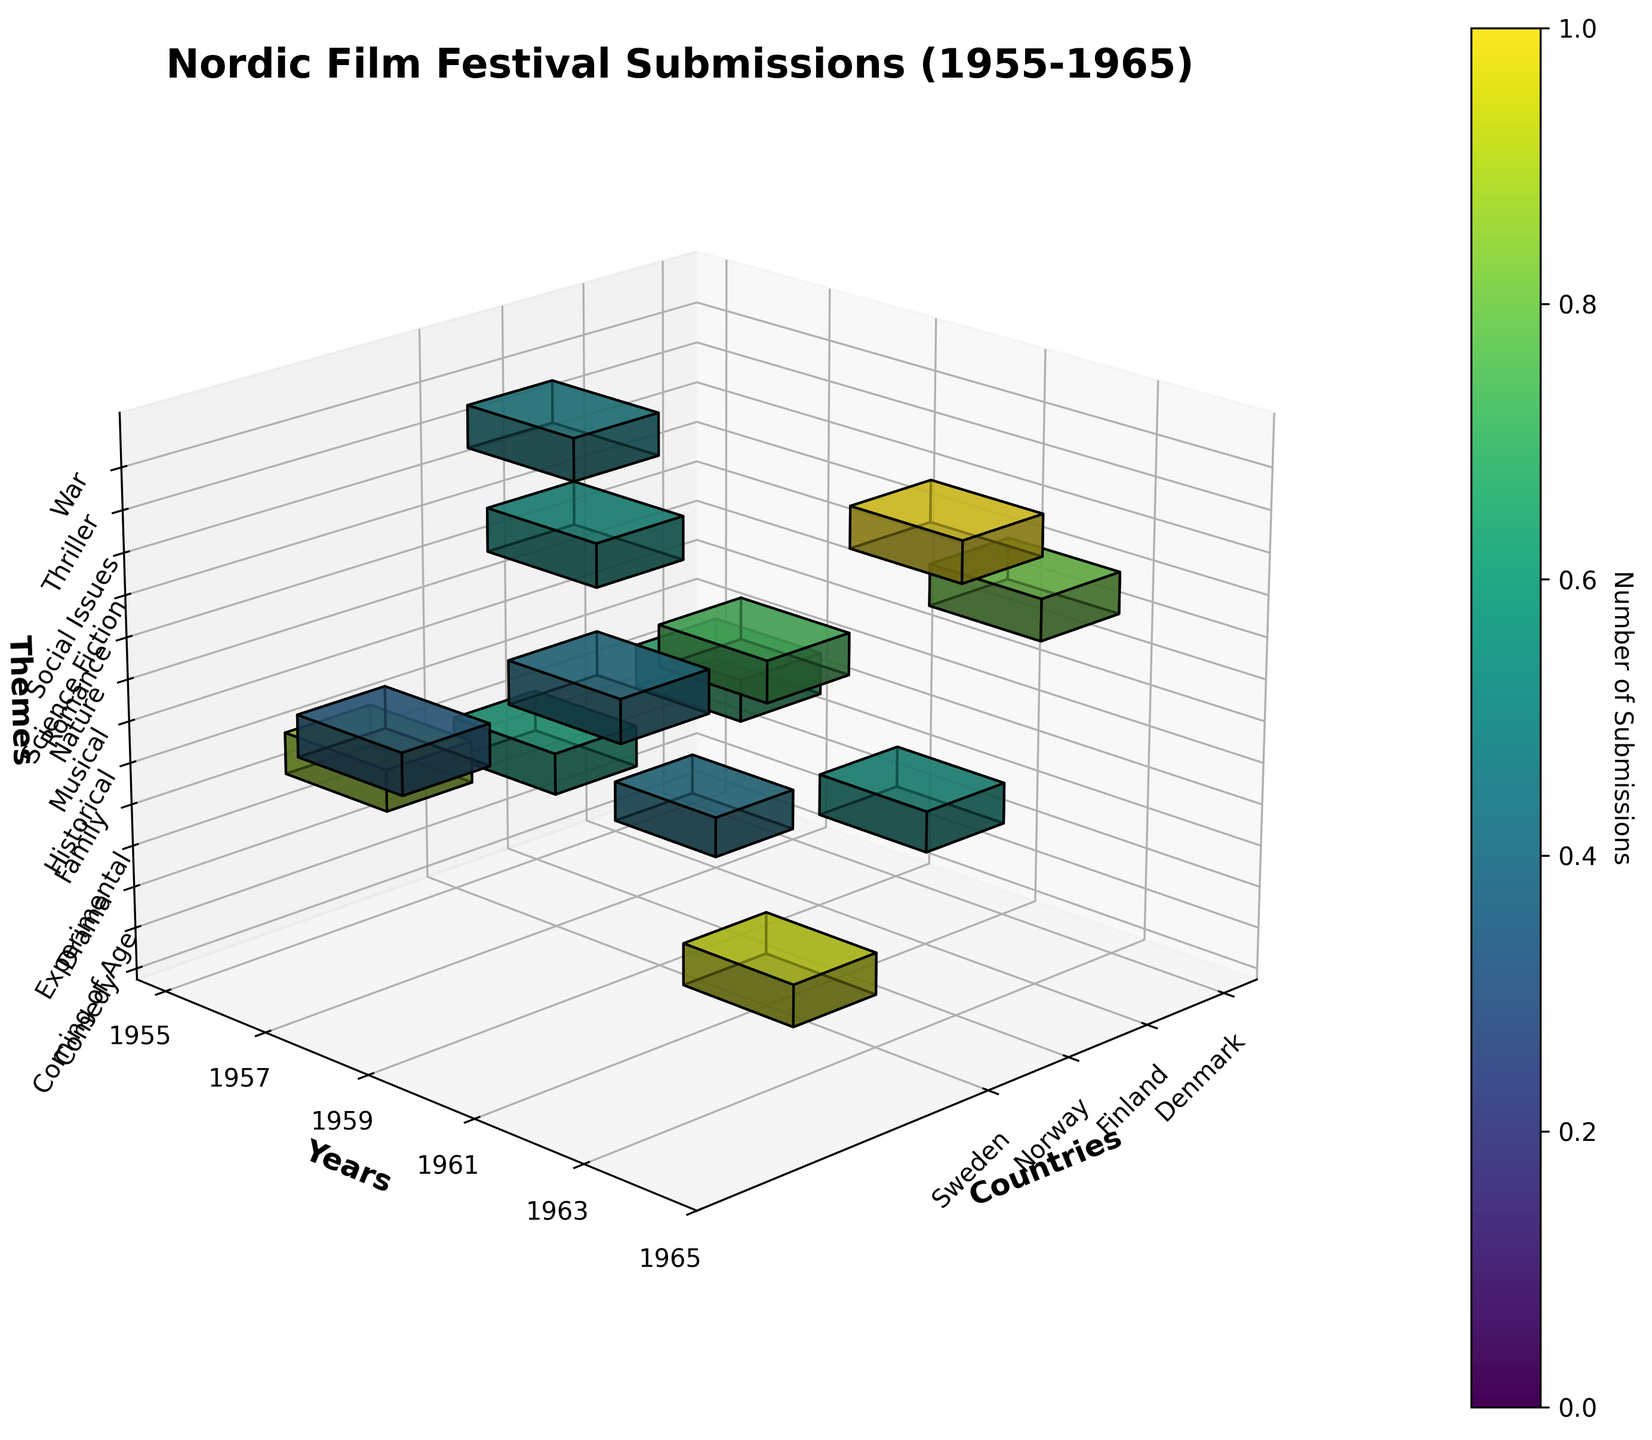what is the title of the figure? The title can be found at the top of the plot. It provides an overview of what the data represents. The title is "Nordic Film Festival Submissions (1955-1965)".
Answer: Nordic Film Festival Submissions (1955-1965) How many countries are represented in the plot? To find the number of countries, look at the x-axis ticks and labels. The countries listed are Sweden, Norway, Denmark, and Finland. So, there are 4 countries in total.
Answer: 4 Which theme has the highest number of submissions from Sweden? Look for the highest voxel in the Sweden column. The highest voxel for Sweden is in the year 1957 under the theme Social Issues, with 15 submissions.
Answer: Social Issues In 1963, which country had the highest number of submissions and what was the theme? Look at the 1963 row in the y-axis and find the highest voxel. The highest submission is for Denmark with the theme "Family," having 13 submissions.
Answer: Denmark, Family Which year had the highest total submissions across all countries and themes? To determine this, sum all the submissions for each year and compare the totals. The year 1957 has the highest total submissions (10 from Finland + 15 from Sweden = 25).
Answer: 1957 What is the total number of submissions for experimental and historical themes across all years and countries? Sum the submissions from the Experimental (1959, Denmark, 9) and Historical (1957, Finland, 10) themes. The total is 9 + 10 = 19.
Answer: 19 Which country has the highest cumulative number of submissions over the decade? Sum the submissions for each country across all years and themes. Sweden has the highest cumulative number with a total of 12 (1955) + 15 (1957) + 14 (1961) + 6 (1965) = 47 submissions.
Answer: Sweden Did any country have zero submissions in a given year? See if any country column has no voxels in any year row. For instance, in 1957, Denmark and Norway have no submissions.
Answer: Yes Comparing Sweden and Finland, which country had more total submissions for romance and war themes combined? Sum the submissions for the respective themes for each country. Sweden (Romance: 12) doesn’t have a War theme, and Finland (War: 7) doesn’t have a Romance theme. Thus, Sweden has 12 and Finland has 7.
Answer: Sweden What is the average number of submissions per year for Norway? Find the total number of submissions for Norway and divide by the number of years it had submissions. Norway's submissions: 8 (1955) + 11 (1959) + 8 (1963) = 27. Norway submitted films in 3 different years, hence the average is 27/3 = 9.
Answer: 9 